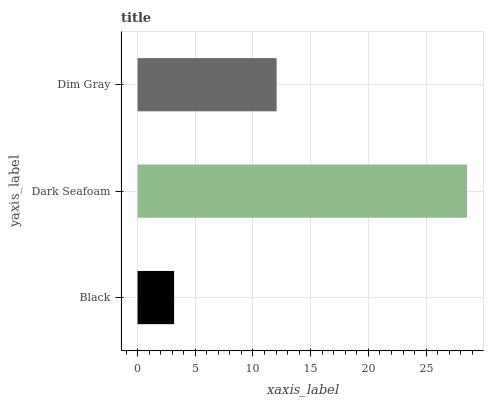Is Black the minimum?
Answer yes or no. Yes. Is Dark Seafoam the maximum?
Answer yes or no. Yes. Is Dim Gray the minimum?
Answer yes or no. No. Is Dim Gray the maximum?
Answer yes or no. No. Is Dark Seafoam greater than Dim Gray?
Answer yes or no. Yes. Is Dim Gray less than Dark Seafoam?
Answer yes or no. Yes. Is Dim Gray greater than Dark Seafoam?
Answer yes or no. No. Is Dark Seafoam less than Dim Gray?
Answer yes or no. No. Is Dim Gray the high median?
Answer yes or no. Yes. Is Dim Gray the low median?
Answer yes or no. Yes. Is Black the high median?
Answer yes or no. No. Is Black the low median?
Answer yes or no. No. 